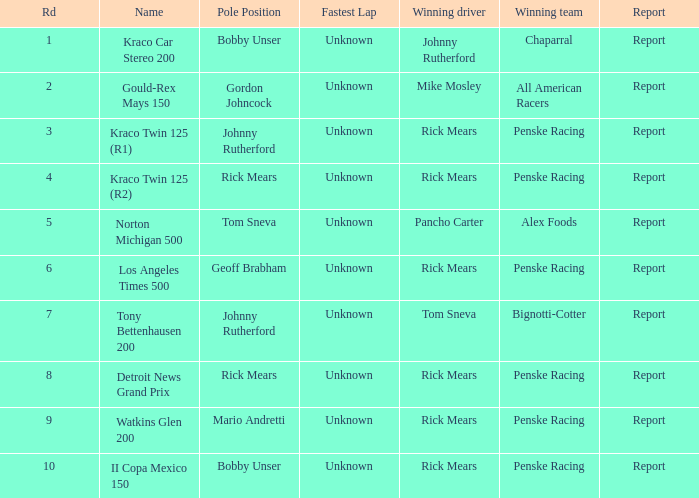The race tony bettenhausen 200 has what smallest rd? 7.0. 